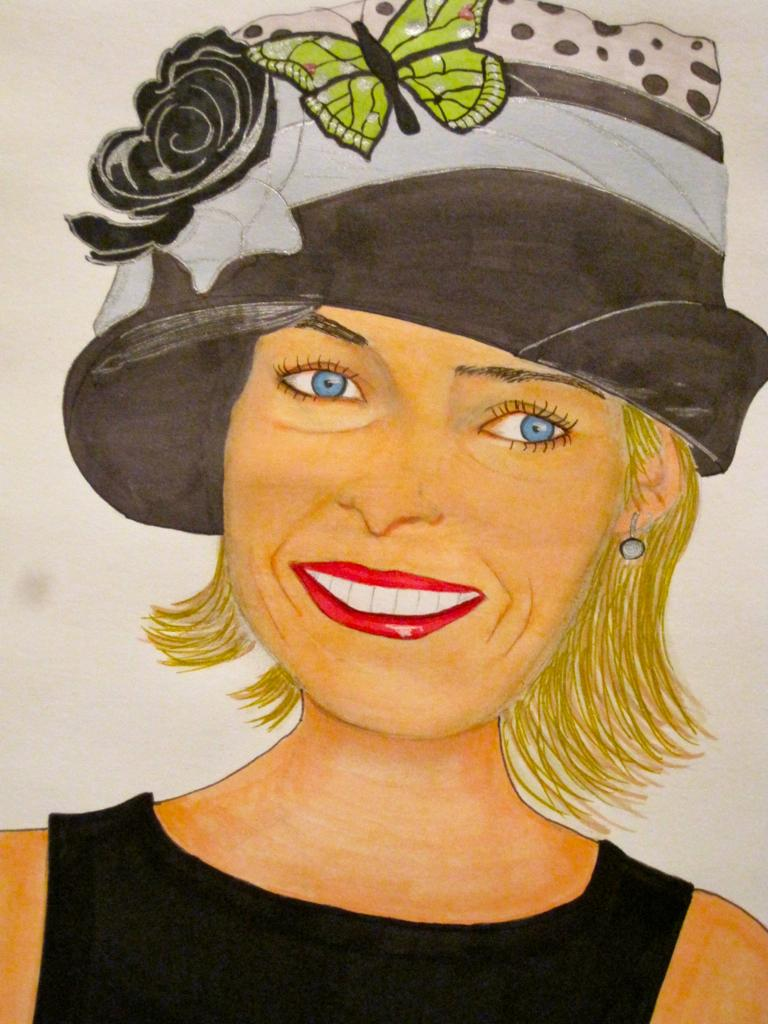What is the main subject of the painting in the image? The painting features a woman. What is the woman wearing on her head? The woman is wearing a hat. Are there any additional elements on the hat? Yes, there is a flower and a butterfly on the hat. What type of queen is depicted in the painting? There is no queen depicted in the painting; it features a woman wearing a hat with a flower and a butterfly. What form of fiction is the painting based on? The painting is not based on any form of fiction; it is a visual representation of a woman wearing a hat with a flower and a butterfly. 